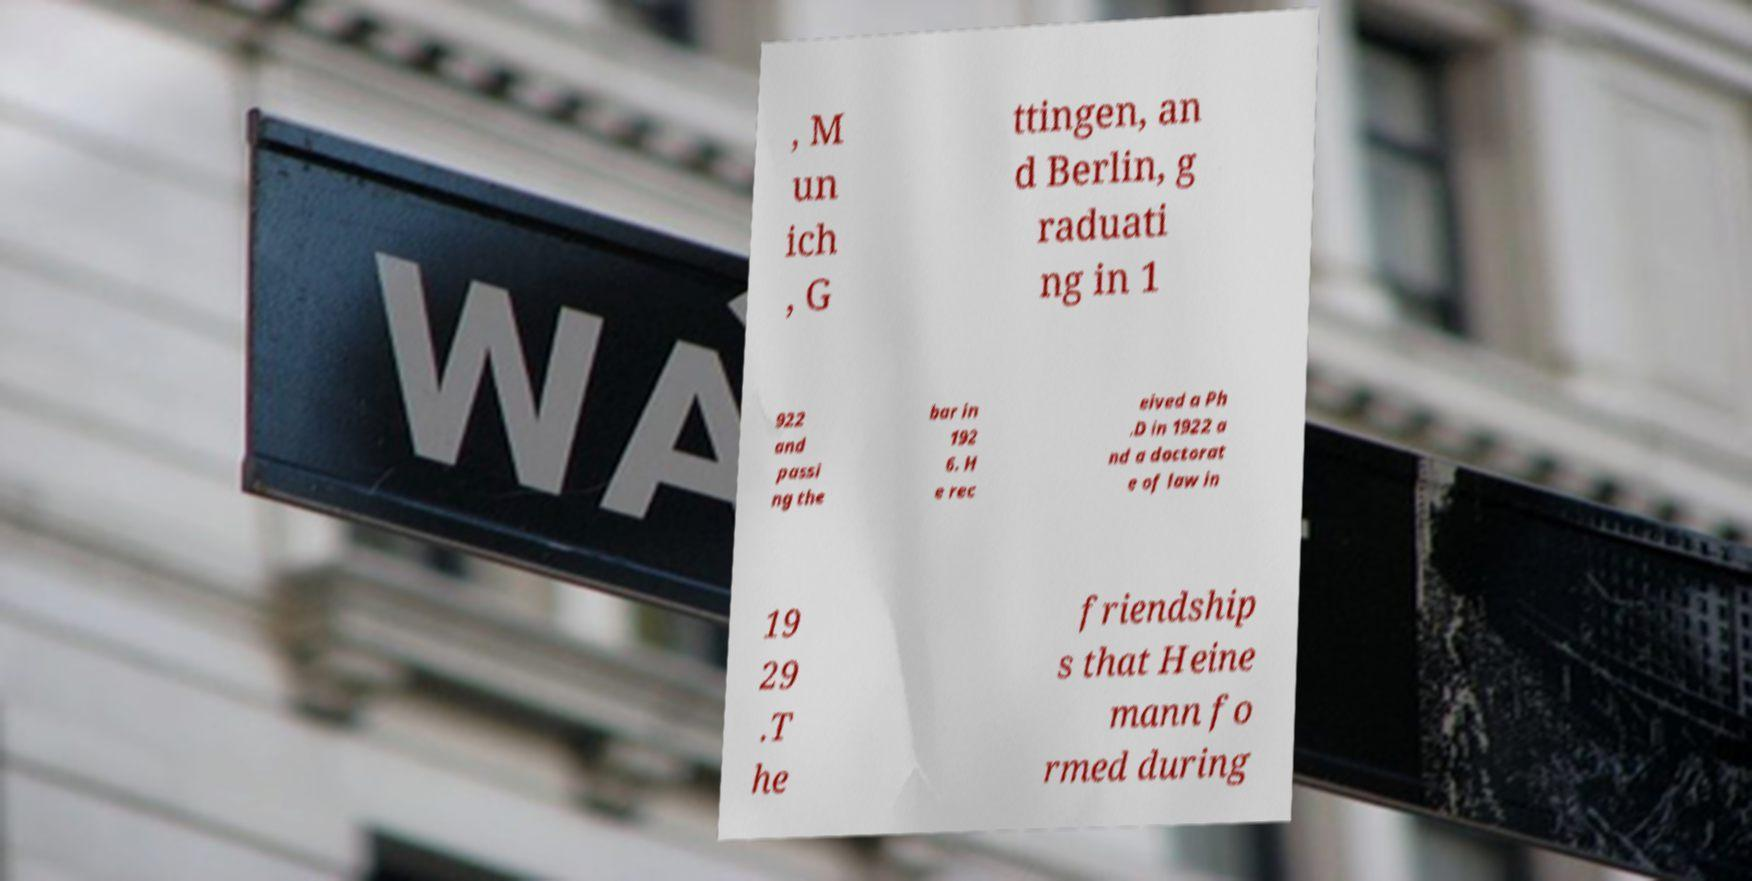There's text embedded in this image that I need extracted. Can you transcribe it verbatim? , M un ich , G ttingen, an d Berlin, g raduati ng in 1 922 and passi ng the bar in 192 6. H e rec eived a Ph .D in 1922 a nd a doctorat e of law in 19 29 .T he friendship s that Heine mann fo rmed during 